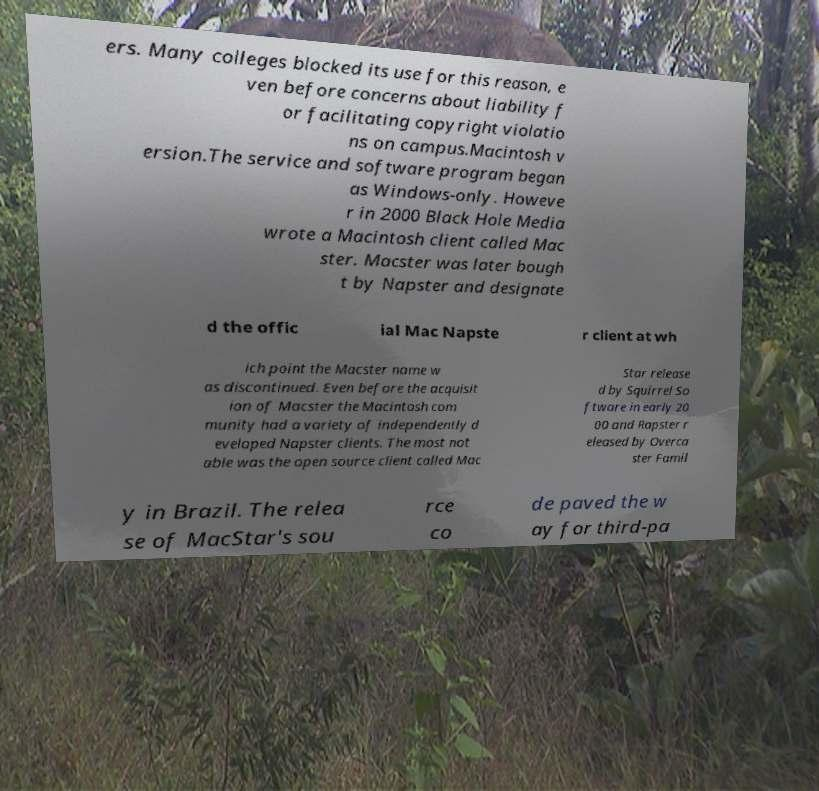Please identify and transcribe the text found in this image. ers. Many colleges blocked its use for this reason, e ven before concerns about liability f or facilitating copyright violatio ns on campus.Macintosh v ersion.The service and software program began as Windows-only. Howeve r in 2000 Black Hole Media wrote a Macintosh client called Mac ster. Macster was later bough t by Napster and designate d the offic ial Mac Napste r client at wh ich point the Macster name w as discontinued. Even before the acquisit ion of Macster the Macintosh com munity had a variety of independently d eveloped Napster clients. The most not able was the open source client called Mac Star release d by Squirrel So ftware in early 20 00 and Rapster r eleased by Overca ster Famil y in Brazil. The relea se of MacStar's sou rce co de paved the w ay for third-pa 